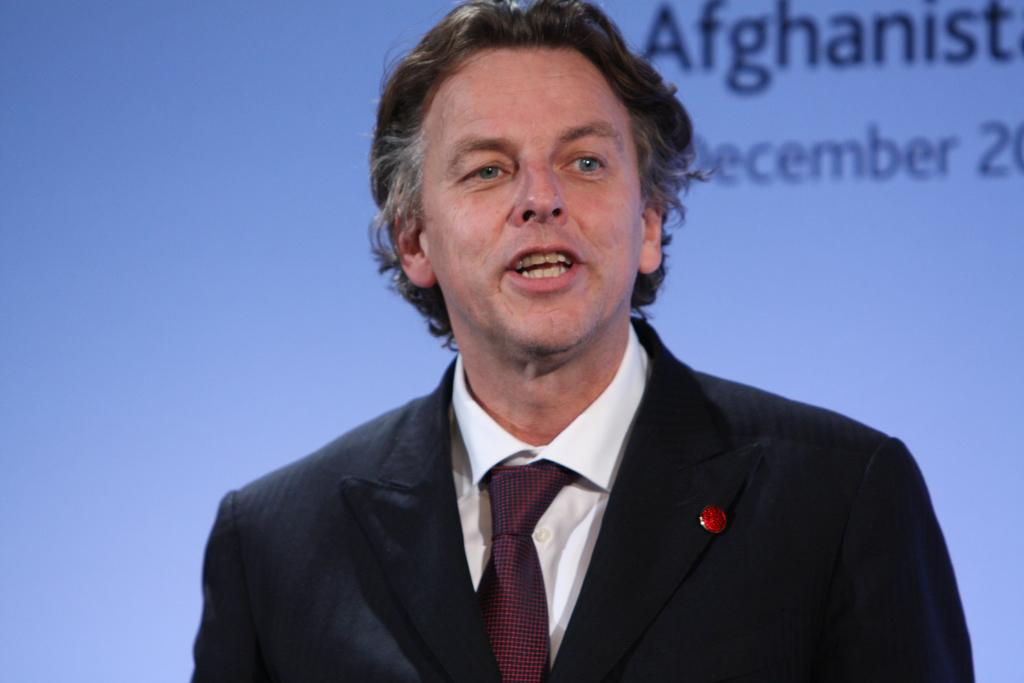Who is present in the image? There is a man in the image. What is the man wearing? The man is wearing a black coat. What can be seen in the background of the image? There is a wall in the background of the image. What is written or depicted on the wall in the background? There is text on the wall in the background. How many pies are displayed on the wall in the image? There are no pies present in the image; the wall has text on it. What type of worm can be seen crawling on the man's coat in the image? There are no worms present in the image; the man is wearing a black coat. 